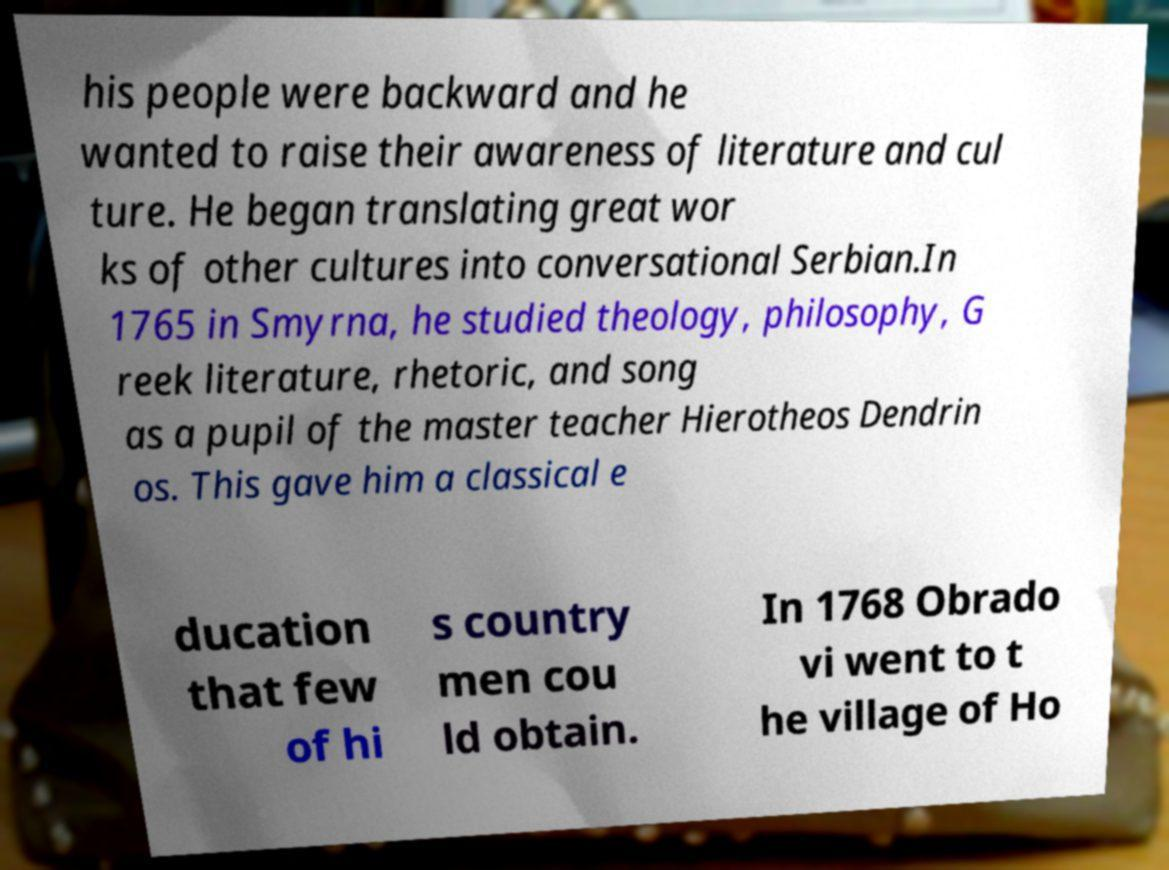Can you read and provide the text displayed in the image?This photo seems to have some interesting text. Can you extract and type it out for me? his people were backward and he wanted to raise their awareness of literature and cul ture. He began translating great wor ks of other cultures into conversational Serbian.In 1765 in Smyrna, he studied theology, philosophy, G reek literature, rhetoric, and song as a pupil of the master teacher Hierotheos Dendrin os. This gave him a classical e ducation that few of hi s country men cou ld obtain. In 1768 Obrado vi went to t he village of Ho 